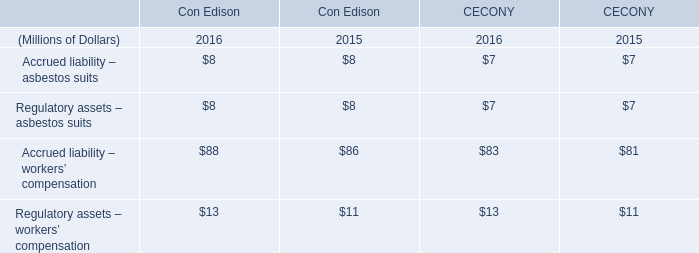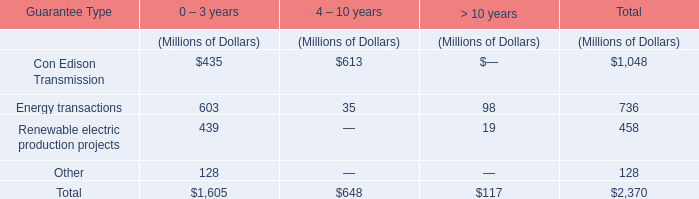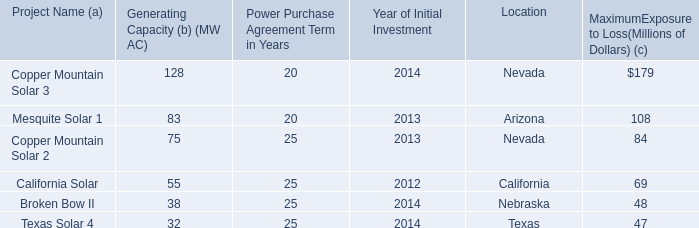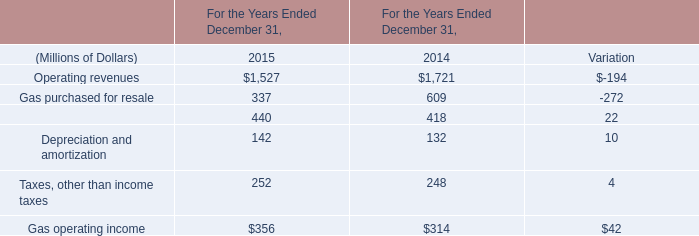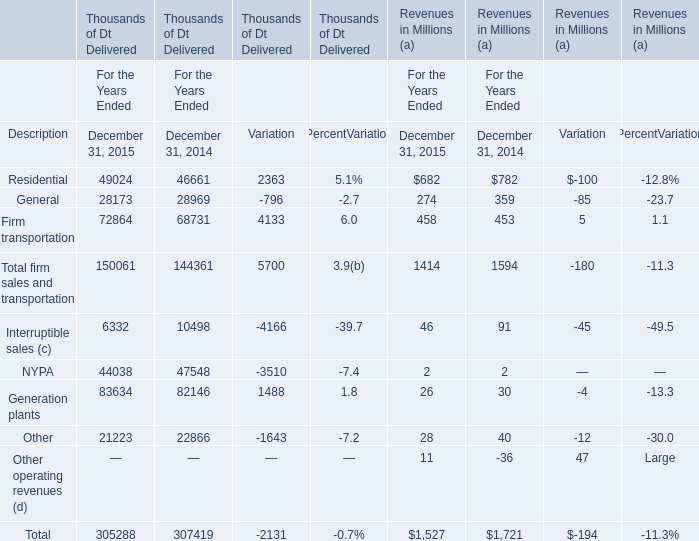In what year is general revenues greater than 200 million? 
Answer: 2014,2015. 